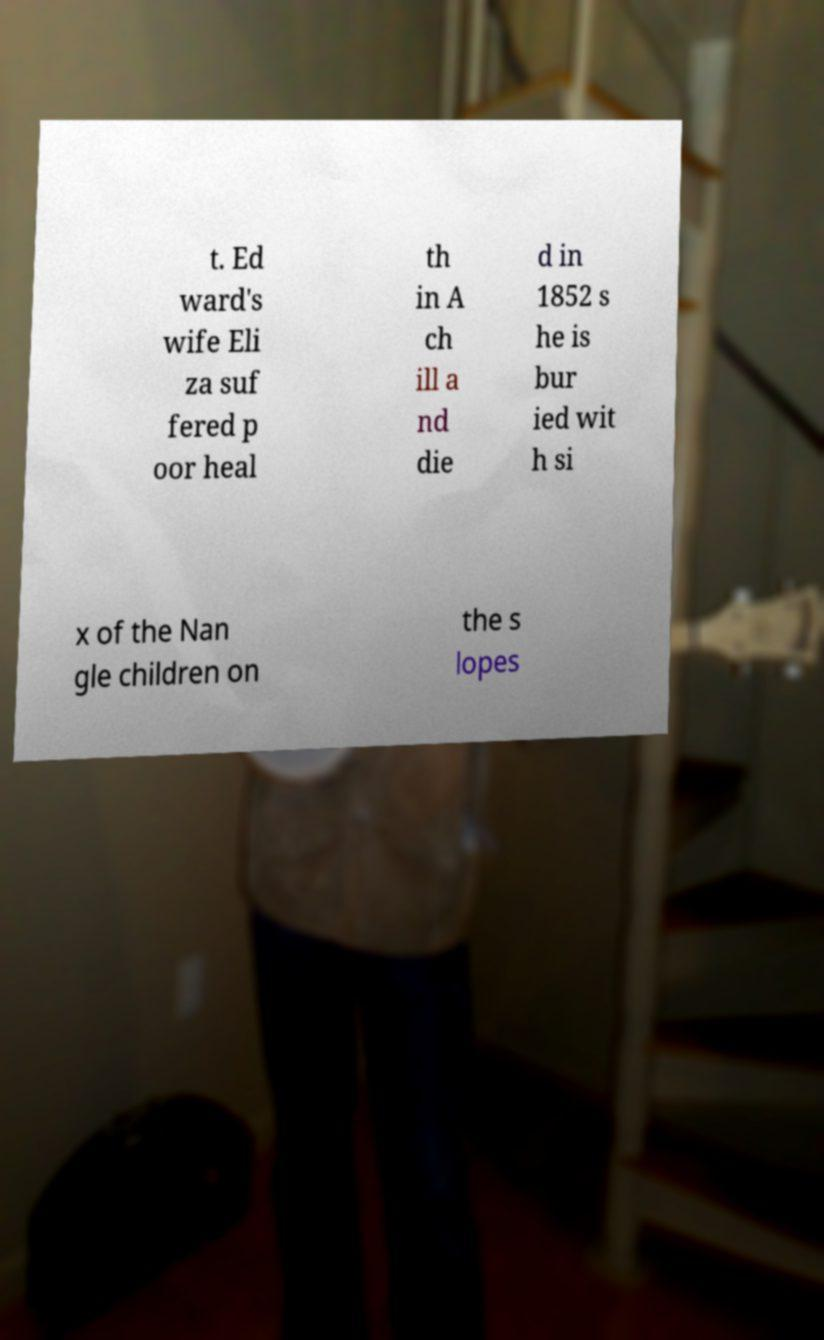Could you assist in decoding the text presented in this image and type it out clearly? t. Ed ward's wife Eli za suf fered p oor heal th in A ch ill a nd die d in 1852 s he is bur ied wit h si x of the Nan gle children on the s lopes 